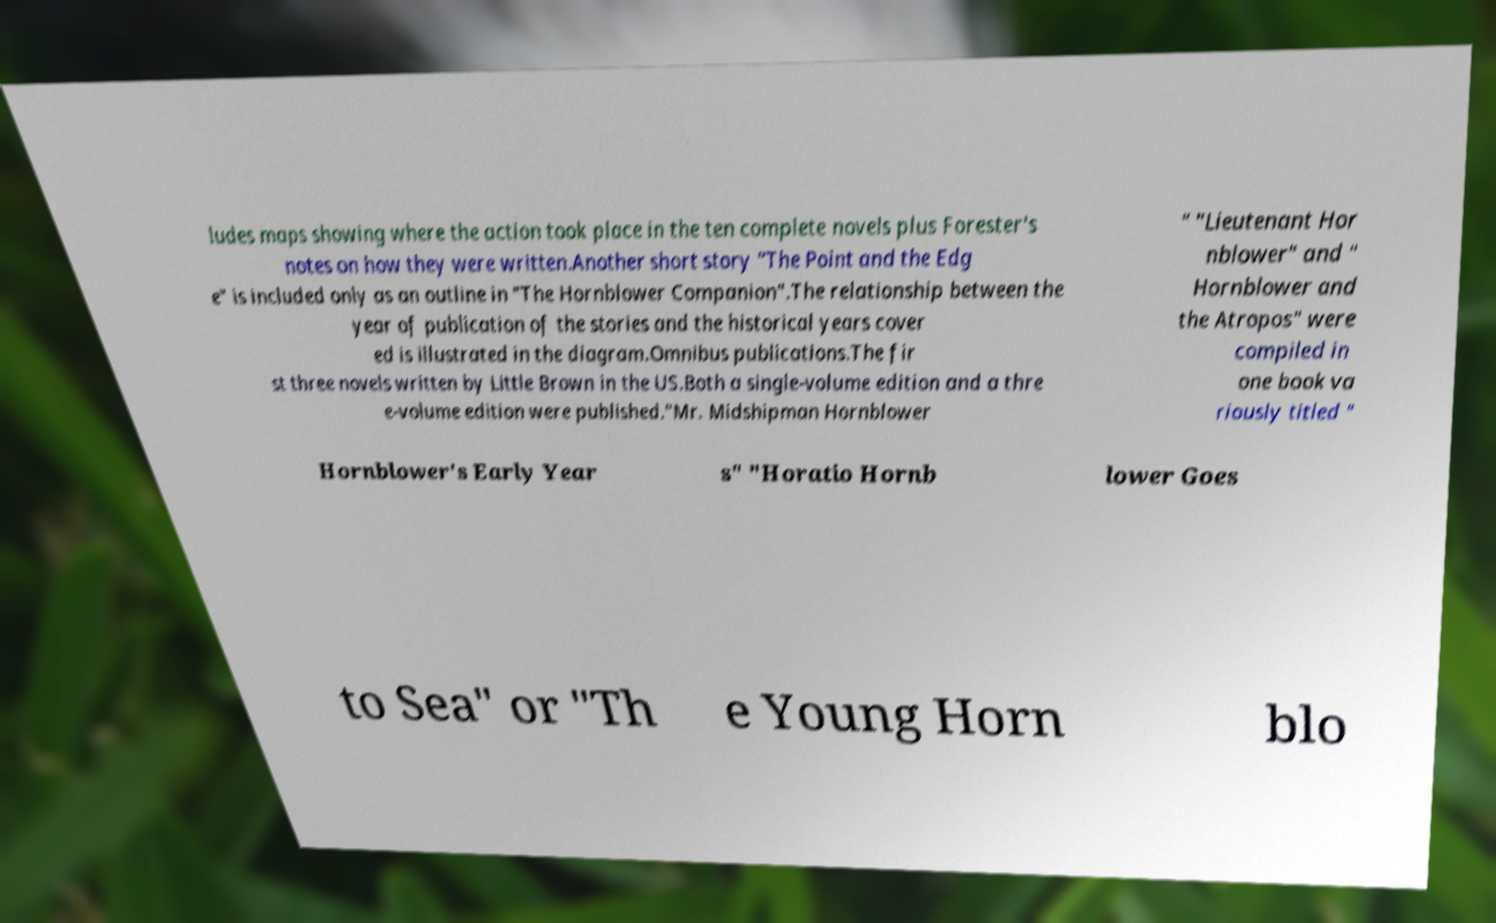I need the written content from this picture converted into text. Can you do that? ludes maps showing where the action took place in the ten complete novels plus Forester's notes on how they were written.Another short story "The Point and the Edg e" is included only as an outline in "The Hornblower Companion".The relationship between the year of publication of the stories and the historical years cover ed is illustrated in the diagram.Omnibus publications.The fir st three novels written by Little Brown in the US.Both a single-volume edition and a thre e-volume edition were published."Mr. Midshipman Hornblower " "Lieutenant Hor nblower" and " Hornblower and the Atropos" were compiled in one book va riously titled " Hornblower's Early Year s" "Horatio Hornb lower Goes to Sea" or "Th e Young Horn blo 